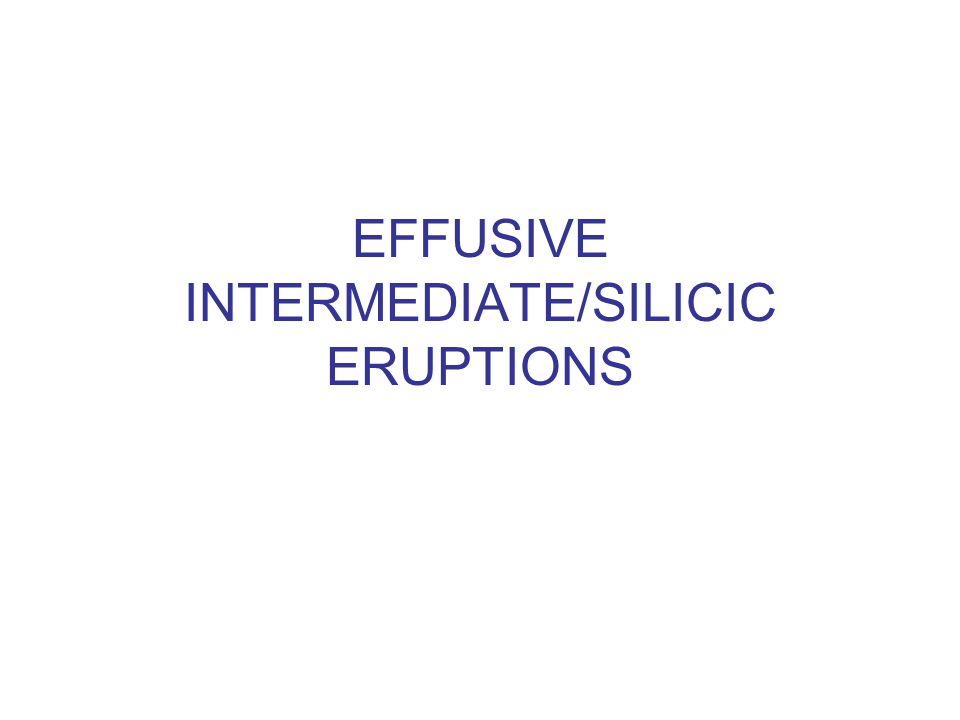Could you explain why the silica content in lava is significant in determining the type of volcanic eruption? The silica content in lava plays a crucial role in determining the type of volcanic eruption because it affects the lava's viscosity. High silica content results in high viscosity, making it thicker and more prone to trapping gases. This build-up can lead to explosive eruptions as the pressure to release gas increases. Conversely, low silica lava is less viscous, flows more freely, and typically results in effusive eruptions, where lava spreads more gently. 